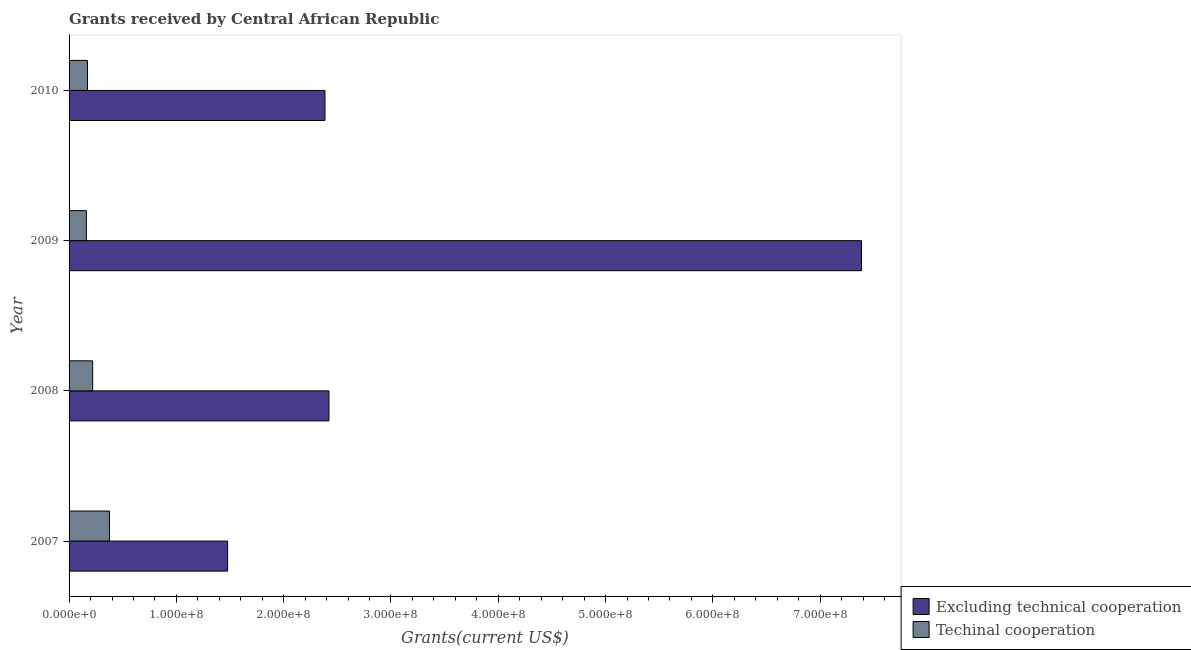How many groups of bars are there?
Keep it short and to the point. 4. Are the number of bars per tick equal to the number of legend labels?
Offer a terse response. Yes. Are the number of bars on each tick of the Y-axis equal?
Your answer should be very brief. Yes. How many bars are there on the 3rd tick from the bottom?
Your answer should be compact. 2. In how many cases, is the number of bars for a given year not equal to the number of legend labels?
Ensure brevity in your answer.  0. What is the amount of grants received(including technical cooperation) in 2009?
Make the answer very short. 1.61e+07. Across all years, what is the maximum amount of grants received(including technical cooperation)?
Provide a short and direct response. 3.77e+07. Across all years, what is the minimum amount of grants received(excluding technical cooperation)?
Provide a succinct answer. 1.48e+08. In which year was the amount of grants received(excluding technical cooperation) maximum?
Keep it short and to the point. 2009. In which year was the amount of grants received(excluding technical cooperation) minimum?
Give a very brief answer. 2007. What is the total amount of grants received(excluding technical cooperation) in the graph?
Make the answer very short. 1.37e+09. What is the difference between the amount of grants received(excluding technical cooperation) in 2008 and that in 2010?
Keep it short and to the point. 3.71e+06. What is the difference between the amount of grants received(excluding technical cooperation) in 2010 and the amount of grants received(including technical cooperation) in 2008?
Give a very brief answer. 2.16e+08. What is the average amount of grants received(including technical cooperation) per year?
Make the answer very short. 2.32e+07. In the year 2010, what is the difference between the amount of grants received(including technical cooperation) and amount of grants received(excluding technical cooperation)?
Your answer should be compact. -2.21e+08. What is the ratio of the amount of grants received(including technical cooperation) in 2007 to that in 2008?
Keep it short and to the point. 1.71. Is the amount of grants received(including technical cooperation) in 2009 less than that in 2010?
Provide a short and direct response. Yes. Is the difference between the amount of grants received(including technical cooperation) in 2009 and 2010 greater than the difference between the amount of grants received(excluding technical cooperation) in 2009 and 2010?
Offer a terse response. No. What is the difference between the highest and the second highest amount of grants received(including technical cooperation)?
Your answer should be compact. 1.57e+07. What is the difference between the highest and the lowest amount of grants received(including technical cooperation)?
Ensure brevity in your answer.  2.16e+07. Is the sum of the amount of grants received(including technical cooperation) in 2008 and 2010 greater than the maximum amount of grants received(excluding technical cooperation) across all years?
Keep it short and to the point. No. What does the 1st bar from the top in 2007 represents?
Offer a terse response. Techinal cooperation. What does the 2nd bar from the bottom in 2007 represents?
Ensure brevity in your answer.  Techinal cooperation. How many bars are there?
Give a very brief answer. 8. Are all the bars in the graph horizontal?
Offer a terse response. Yes. How many years are there in the graph?
Make the answer very short. 4. What is the difference between two consecutive major ticks on the X-axis?
Your response must be concise. 1.00e+08. Where does the legend appear in the graph?
Provide a succinct answer. Bottom right. What is the title of the graph?
Your answer should be compact. Grants received by Central African Republic. What is the label or title of the X-axis?
Give a very brief answer. Grants(current US$). What is the Grants(current US$) of Excluding technical cooperation in 2007?
Give a very brief answer. 1.48e+08. What is the Grants(current US$) of Techinal cooperation in 2007?
Keep it short and to the point. 3.77e+07. What is the Grants(current US$) in Excluding technical cooperation in 2008?
Give a very brief answer. 2.42e+08. What is the Grants(current US$) of Techinal cooperation in 2008?
Make the answer very short. 2.20e+07. What is the Grants(current US$) in Excluding technical cooperation in 2009?
Offer a very short reply. 7.38e+08. What is the Grants(current US$) of Techinal cooperation in 2009?
Offer a very short reply. 1.61e+07. What is the Grants(current US$) in Excluding technical cooperation in 2010?
Your answer should be very brief. 2.38e+08. What is the Grants(current US$) in Techinal cooperation in 2010?
Provide a succinct answer. 1.72e+07. Across all years, what is the maximum Grants(current US$) in Excluding technical cooperation?
Keep it short and to the point. 7.38e+08. Across all years, what is the maximum Grants(current US$) of Techinal cooperation?
Make the answer very short. 3.77e+07. Across all years, what is the minimum Grants(current US$) of Excluding technical cooperation?
Offer a terse response. 1.48e+08. Across all years, what is the minimum Grants(current US$) of Techinal cooperation?
Keep it short and to the point. 1.61e+07. What is the total Grants(current US$) of Excluding technical cooperation in the graph?
Give a very brief answer. 1.37e+09. What is the total Grants(current US$) in Techinal cooperation in the graph?
Offer a terse response. 9.29e+07. What is the difference between the Grants(current US$) in Excluding technical cooperation in 2007 and that in 2008?
Provide a succinct answer. -9.45e+07. What is the difference between the Grants(current US$) in Techinal cooperation in 2007 and that in 2008?
Keep it short and to the point. 1.57e+07. What is the difference between the Grants(current US$) of Excluding technical cooperation in 2007 and that in 2009?
Provide a short and direct response. -5.91e+08. What is the difference between the Grants(current US$) of Techinal cooperation in 2007 and that in 2009?
Your response must be concise. 2.16e+07. What is the difference between the Grants(current US$) of Excluding technical cooperation in 2007 and that in 2010?
Your response must be concise. -9.08e+07. What is the difference between the Grants(current US$) of Techinal cooperation in 2007 and that in 2010?
Give a very brief answer. 2.05e+07. What is the difference between the Grants(current US$) of Excluding technical cooperation in 2008 and that in 2009?
Make the answer very short. -4.96e+08. What is the difference between the Grants(current US$) in Techinal cooperation in 2008 and that in 2009?
Keep it short and to the point. 5.90e+06. What is the difference between the Grants(current US$) in Excluding technical cooperation in 2008 and that in 2010?
Offer a very short reply. 3.71e+06. What is the difference between the Grants(current US$) in Techinal cooperation in 2008 and that in 2010?
Your answer should be compact. 4.84e+06. What is the difference between the Grants(current US$) in Excluding technical cooperation in 2009 and that in 2010?
Offer a very short reply. 5.00e+08. What is the difference between the Grants(current US$) of Techinal cooperation in 2009 and that in 2010?
Your answer should be very brief. -1.06e+06. What is the difference between the Grants(current US$) in Excluding technical cooperation in 2007 and the Grants(current US$) in Techinal cooperation in 2008?
Keep it short and to the point. 1.26e+08. What is the difference between the Grants(current US$) of Excluding technical cooperation in 2007 and the Grants(current US$) of Techinal cooperation in 2009?
Your answer should be very brief. 1.32e+08. What is the difference between the Grants(current US$) in Excluding technical cooperation in 2007 and the Grants(current US$) in Techinal cooperation in 2010?
Give a very brief answer. 1.31e+08. What is the difference between the Grants(current US$) in Excluding technical cooperation in 2008 and the Grants(current US$) in Techinal cooperation in 2009?
Your answer should be very brief. 2.26e+08. What is the difference between the Grants(current US$) in Excluding technical cooperation in 2008 and the Grants(current US$) in Techinal cooperation in 2010?
Your answer should be very brief. 2.25e+08. What is the difference between the Grants(current US$) of Excluding technical cooperation in 2009 and the Grants(current US$) of Techinal cooperation in 2010?
Provide a succinct answer. 7.21e+08. What is the average Grants(current US$) of Excluding technical cooperation per year?
Your answer should be compact. 3.42e+08. What is the average Grants(current US$) of Techinal cooperation per year?
Your response must be concise. 2.32e+07. In the year 2007, what is the difference between the Grants(current US$) in Excluding technical cooperation and Grants(current US$) in Techinal cooperation?
Offer a terse response. 1.10e+08. In the year 2008, what is the difference between the Grants(current US$) in Excluding technical cooperation and Grants(current US$) in Techinal cooperation?
Offer a terse response. 2.20e+08. In the year 2009, what is the difference between the Grants(current US$) in Excluding technical cooperation and Grants(current US$) in Techinal cooperation?
Provide a short and direct response. 7.22e+08. In the year 2010, what is the difference between the Grants(current US$) in Excluding technical cooperation and Grants(current US$) in Techinal cooperation?
Provide a short and direct response. 2.21e+08. What is the ratio of the Grants(current US$) of Excluding technical cooperation in 2007 to that in 2008?
Provide a succinct answer. 0.61. What is the ratio of the Grants(current US$) of Techinal cooperation in 2007 to that in 2008?
Offer a terse response. 1.71. What is the ratio of the Grants(current US$) in Techinal cooperation in 2007 to that in 2009?
Provide a succinct answer. 2.34. What is the ratio of the Grants(current US$) in Excluding technical cooperation in 2007 to that in 2010?
Make the answer very short. 0.62. What is the ratio of the Grants(current US$) of Techinal cooperation in 2007 to that in 2010?
Ensure brevity in your answer.  2.2. What is the ratio of the Grants(current US$) in Excluding technical cooperation in 2008 to that in 2009?
Offer a very short reply. 0.33. What is the ratio of the Grants(current US$) of Techinal cooperation in 2008 to that in 2009?
Make the answer very short. 1.37. What is the ratio of the Grants(current US$) in Excluding technical cooperation in 2008 to that in 2010?
Keep it short and to the point. 1.02. What is the ratio of the Grants(current US$) of Techinal cooperation in 2008 to that in 2010?
Provide a short and direct response. 1.28. What is the ratio of the Grants(current US$) of Excluding technical cooperation in 2009 to that in 2010?
Make the answer very short. 3.1. What is the ratio of the Grants(current US$) in Techinal cooperation in 2009 to that in 2010?
Give a very brief answer. 0.94. What is the difference between the highest and the second highest Grants(current US$) of Excluding technical cooperation?
Offer a terse response. 4.96e+08. What is the difference between the highest and the second highest Grants(current US$) of Techinal cooperation?
Your response must be concise. 1.57e+07. What is the difference between the highest and the lowest Grants(current US$) in Excluding technical cooperation?
Offer a terse response. 5.91e+08. What is the difference between the highest and the lowest Grants(current US$) of Techinal cooperation?
Provide a succinct answer. 2.16e+07. 